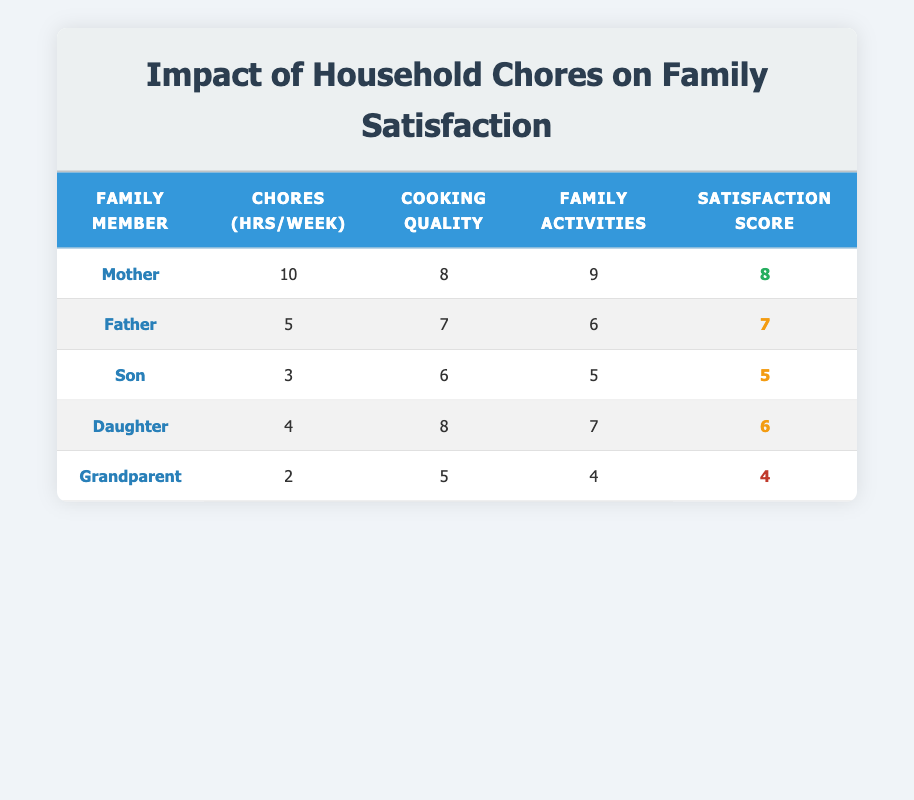What is the Family Satisfaction Score for the Mother? The table lists the Family Satisfaction Score for each family member. For the Mother, it is directly provided as 8.
Answer: 8 What is the Cooking Frequency Perceived Quality for the Grandparent? Looking at the Grandparent's row in the table, the Cooking Frequency Perceived Quality is given as 5.
Answer: 5 Which family member has the highest Chores Assigned Hours per Week? By comparing the Chores Assigned Hours per Week for each family member, the Mother has the highest at 10 hours.
Answer: Mother What is the average Family Satisfaction Score of all family members? To find the average, sum up all the Family Satisfaction Scores: (8 + 7 + 5 + 6 + 4) = 30. Then, divide by the number of family members, which is 5: 30/5 = 6.
Answer: 6 Does the Daughter have a higher Cooking Frequency Perceived Quality than the Son? The Daughter's Cooking Frequency Perceived Quality is 8, while the Son's is 6; since 8 is greater than 6, the answer is yes.
Answer: Yes What is the sum of Chores Assigned Hours per Week for all family members? By summing the Chores Assigned Hours per Week: (10 + 5 + 3 + 4 + 2) = 24 hours.
Answer: 24 Is there any family member with a Family Satisfaction Score of 4? By checking the Family Satisfaction Scores listed, we see that the Grandparent has a score of 4, so the answer is yes.
Answer: Yes What is the difference between the participation in family activities of the Mother and the Grandparent? The Mother's participation score is 9 and the Grandparent's is 4. Calculating the difference: 9 - 4 = 5.
Answer: 5 Which family member has the lowest score in Family Satisfaction? The lowest Family Satisfaction Score listed is 4, which corresponds to the Grandparent.
Answer: Grandparent How many family members have a Family Satisfaction Score of 6 or higher? The Family Satisfaction Scores are 8, 7, 5, 6, and 4. The scores of 6 or higher are 8, 7, and 6. Therefore, there are 3 members with scores of 6 or higher.
Answer: 3 